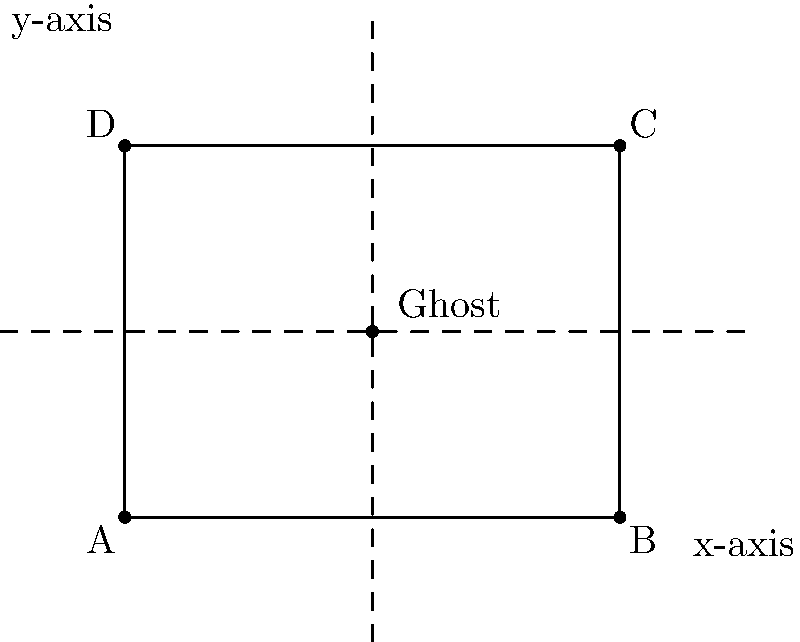In your haunted house, you want to reflect a ghostly figure to create multiple scare points. The ghost's initial position is at point $E(2,1.5)$ in a room represented by the rectangle $ABCD$. If you reflect the ghost across the x-axis and then across the line $x=2$, what will be the final coordinates of the ghost's position? Let's approach this step-by-step:

1) The initial position of the ghost is $E(2,1.5)$.

2) First, we reflect across the x-axis:
   - The x-coordinate remains the same: 2
   - The y-coordinate changes sign: $1.5$ becomes $-1.5$
   - After this reflection, the ghost is at $(2,-1.5)$

3) Next, we reflect across the line $x=2$:
   - This line is a vertical line passing through $x=2$
   - Reflection across a vertical line keeps the y-coordinate the same
   - The x-coordinate is reflected by the same distance on the other side of the line
   - The distance from $x=2$ to the current x-coordinate is $0$
   - So, the new x-coordinate remains $2$

4) Therefore, after both reflections, the ghost's final position is $(2,-1.5)$

This double reflection has effectively moved the ghost from above the x-axis to below it, while keeping it on the same vertical line.
Answer: $(2,-1.5)$ 